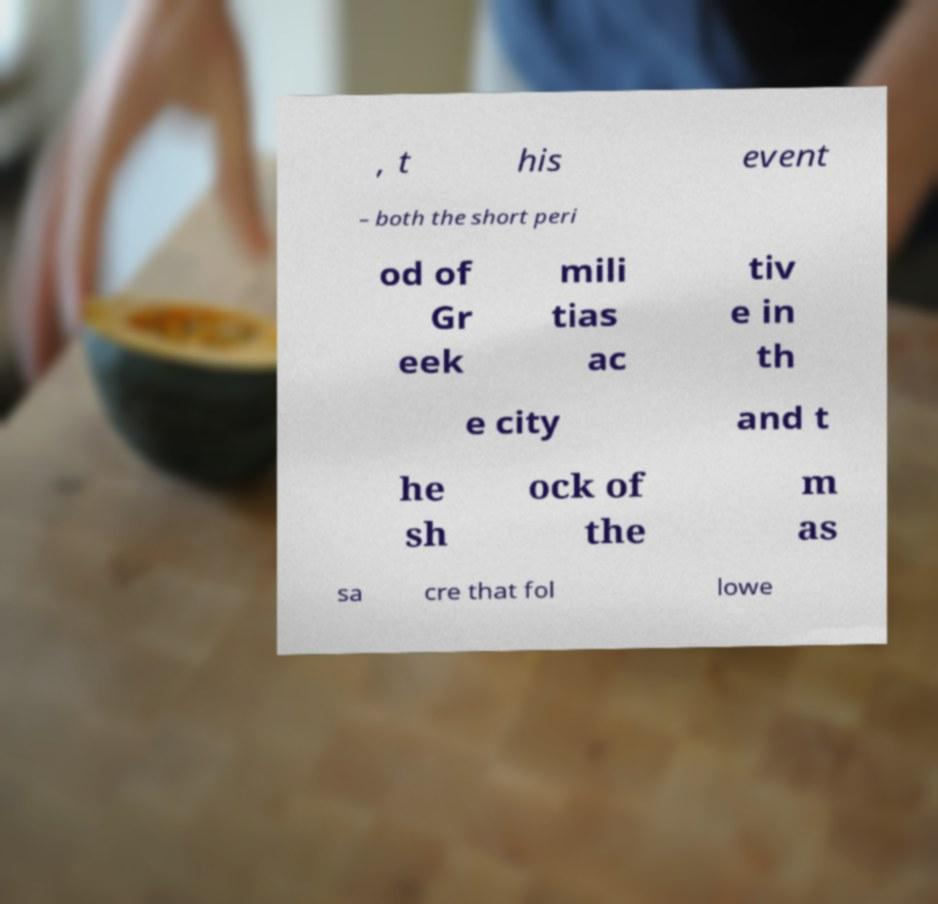Could you assist in decoding the text presented in this image and type it out clearly? , t his event – both the short peri od of Gr eek mili tias ac tiv e in th e city and t he sh ock of the m as sa cre that fol lowe 